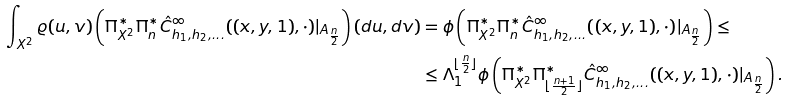<formula> <loc_0><loc_0><loc_500><loc_500>\int _ { X ^ { 2 } } \varrho ( u , v ) \left ( \Pi _ { X ^ { 2 } } ^ { * } \Pi _ { n } ^ { * } \hat { C } _ { h _ { 1 } , h _ { 2 } , \dots } ^ { \infty } ( ( x , y , 1 ) , \cdot ) | _ { A _ { \frac { n } { 2 } } } \right ) ( d u , d v ) & = \phi \left ( \Pi _ { X ^ { 2 } } ^ { * } \Pi _ { n } ^ { * } \hat { C } _ { h _ { 1 } , h _ { 2 } , \dots } ^ { \infty } ( ( x , y , 1 ) , \cdot ) | _ { A _ { \frac { n } { 2 } } } \right ) \leq \\ & \leq \Lambda _ { 1 } ^ { \lfloor \frac { n } { 2 } \rfloor } \phi \left ( \Pi _ { X ^ { 2 } } ^ { * } \Pi _ { \lfloor \frac { n + 1 } { 2 } \rfloor } ^ { * } \hat { C } _ { h _ { 1 } , h _ { 2 } , \dots } ^ { \infty } ( ( x , y , 1 ) , \cdot ) | _ { A _ { \frac { n } { 2 } } } \right ) .</formula> 